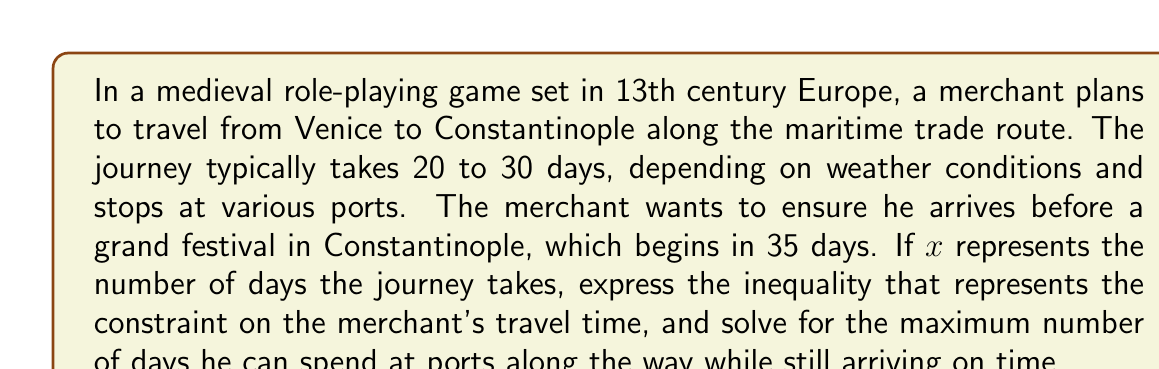Could you help me with this problem? Let's approach this step-by-step:

1) First, we need to set up the inequality. The journey takes at least 20 days and at most 30 days. We can express this as:

   $$ 20 \leq x \leq 30 $$

2) The merchant needs to arrive before the festival, which starts in 35 days. This means:

   $$ x < 35 $$

3) Combining these inequalities, we get:

   $$ 20 \leq x < 35 $$

4) To find the maximum number of days the merchant can spend at ports, we need to calculate the difference between the maximum travel time (which is just under 35 days) and the minimum travel time (20 days).

5) The maximum number of days for stops, let's call it $y$, can be expressed as:

   $$ y = 35 - 20 - \epsilon $$

   Where $\epsilon$ is an infinitesimally small positive number to ensure the merchant arrives strictly before the festival starts.

6) Simplifying:

   $$ y = 15 - \epsilon $$

7) In practical terms, since we're dealing with whole days, this means the merchant can spend at most 14 days at ports along the way.
Answer: The inequality representing the constraint on the merchant's travel time is $20 \leq x < 35$, where $x$ is the number of days the journey takes. The maximum number of days the merchant can spend at ports while still arriving on time is 14 days. 